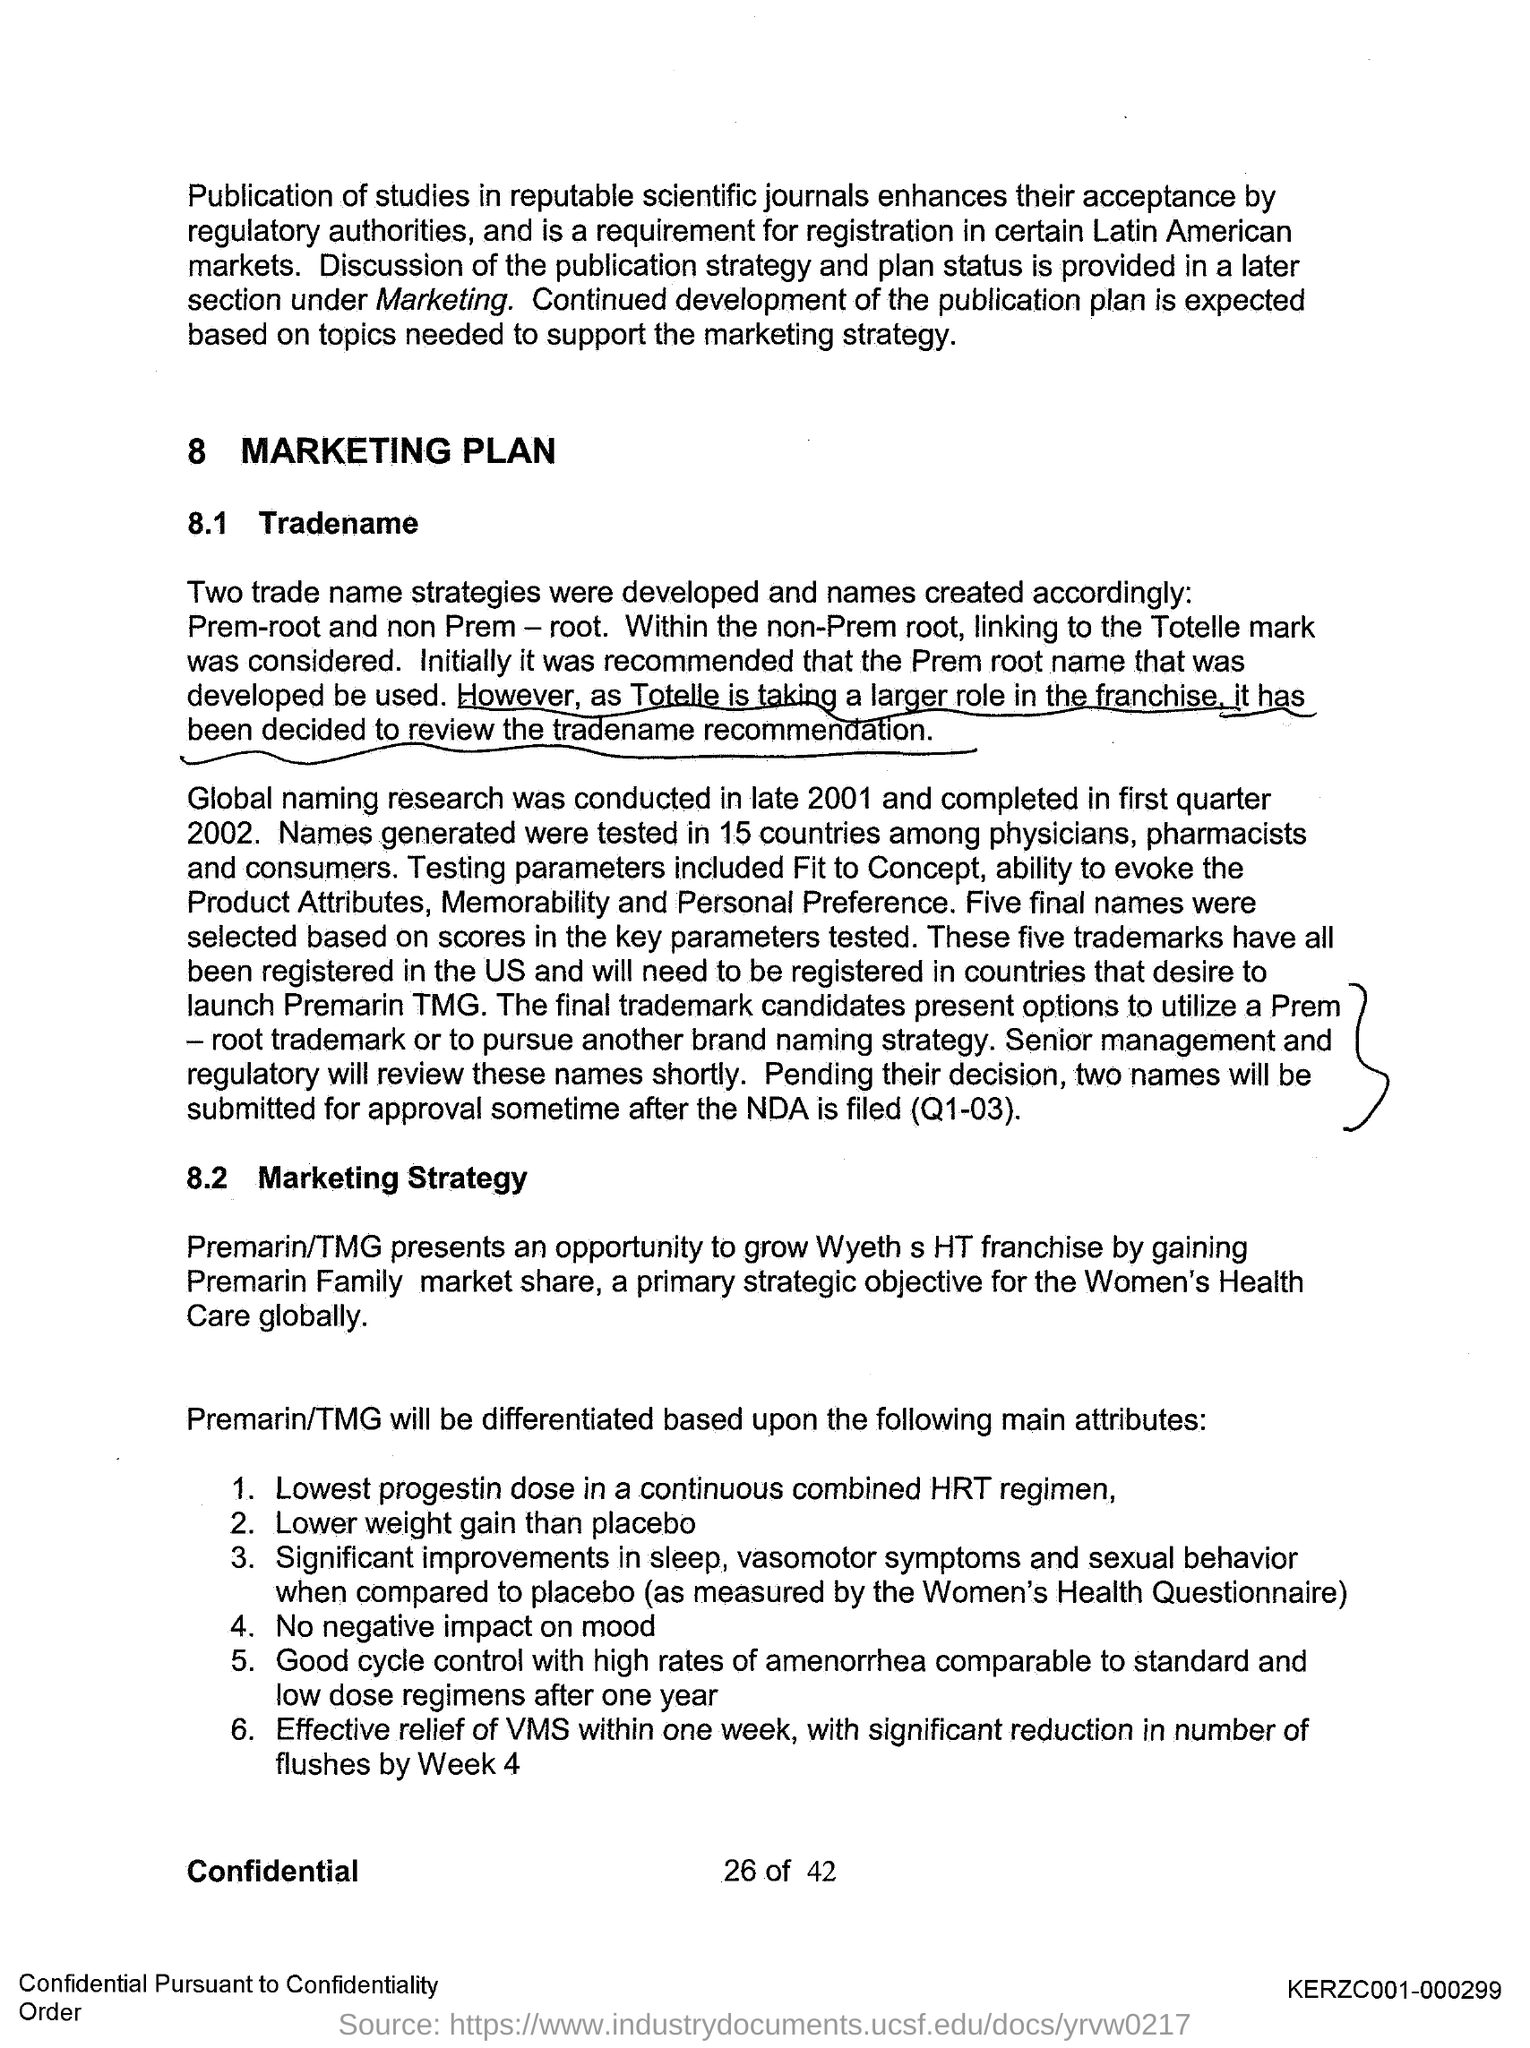What is the first title in the document?
Ensure brevity in your answer.  Marketing Plan. What is the second title in the document?
Offer a terse response. Tradename. What is the third title in the document?
Provide a succinct answer. Marketing Strategy. 